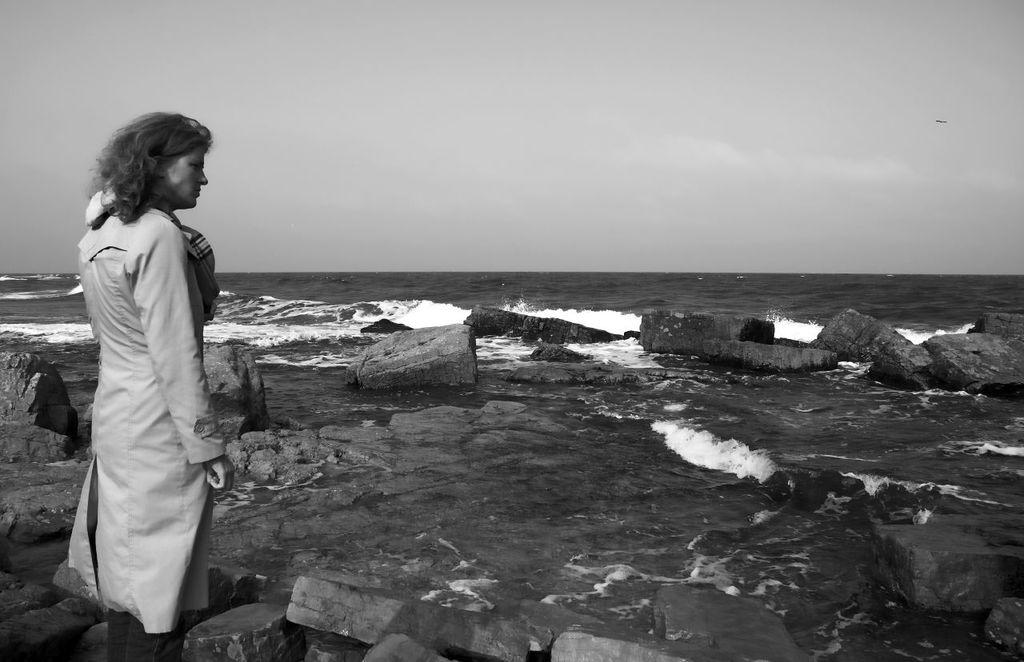What is the main subject of the image? There is a lady standing in the image. What is the lady standing on? The lady is standing on the ground. What type of natural features can be seen in the image? There are rocks and water visible in the image. What part of the natural environment is visible in the image? The sky is visible in the image. How many men are visible in the image? There are no men present in the image; it features a lady standing. What type of leaf can be seen falling from the sky in the image? There is no leaf falling from the sky in the image; only the lady, ground, rocks, water, and sky are present. 